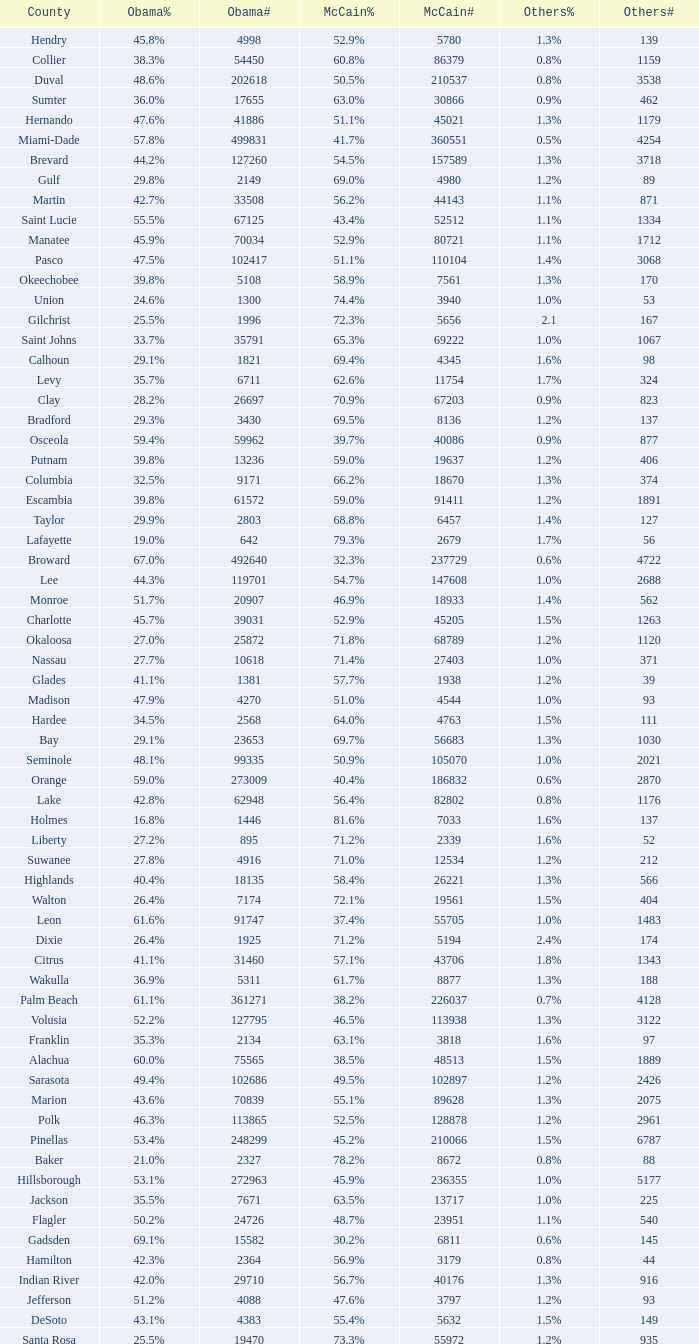What percentage was the others vote when McCain had 52.9% and less than 45205.0 voters? 1.3%. 